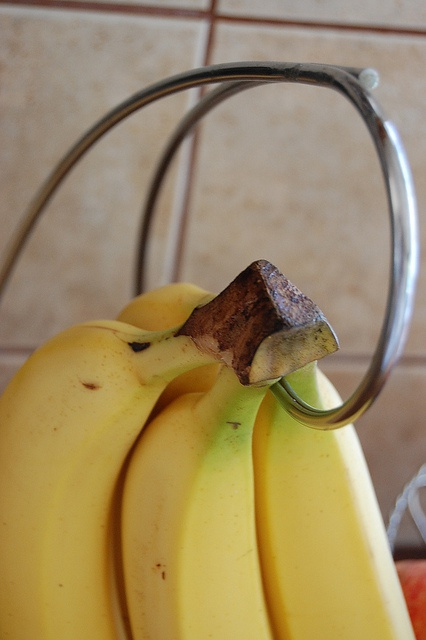Describe the objects in this image and their specific colors. I can see banana in maroon, tan, and olive tones and apple in maroon and brown tones in this image. 